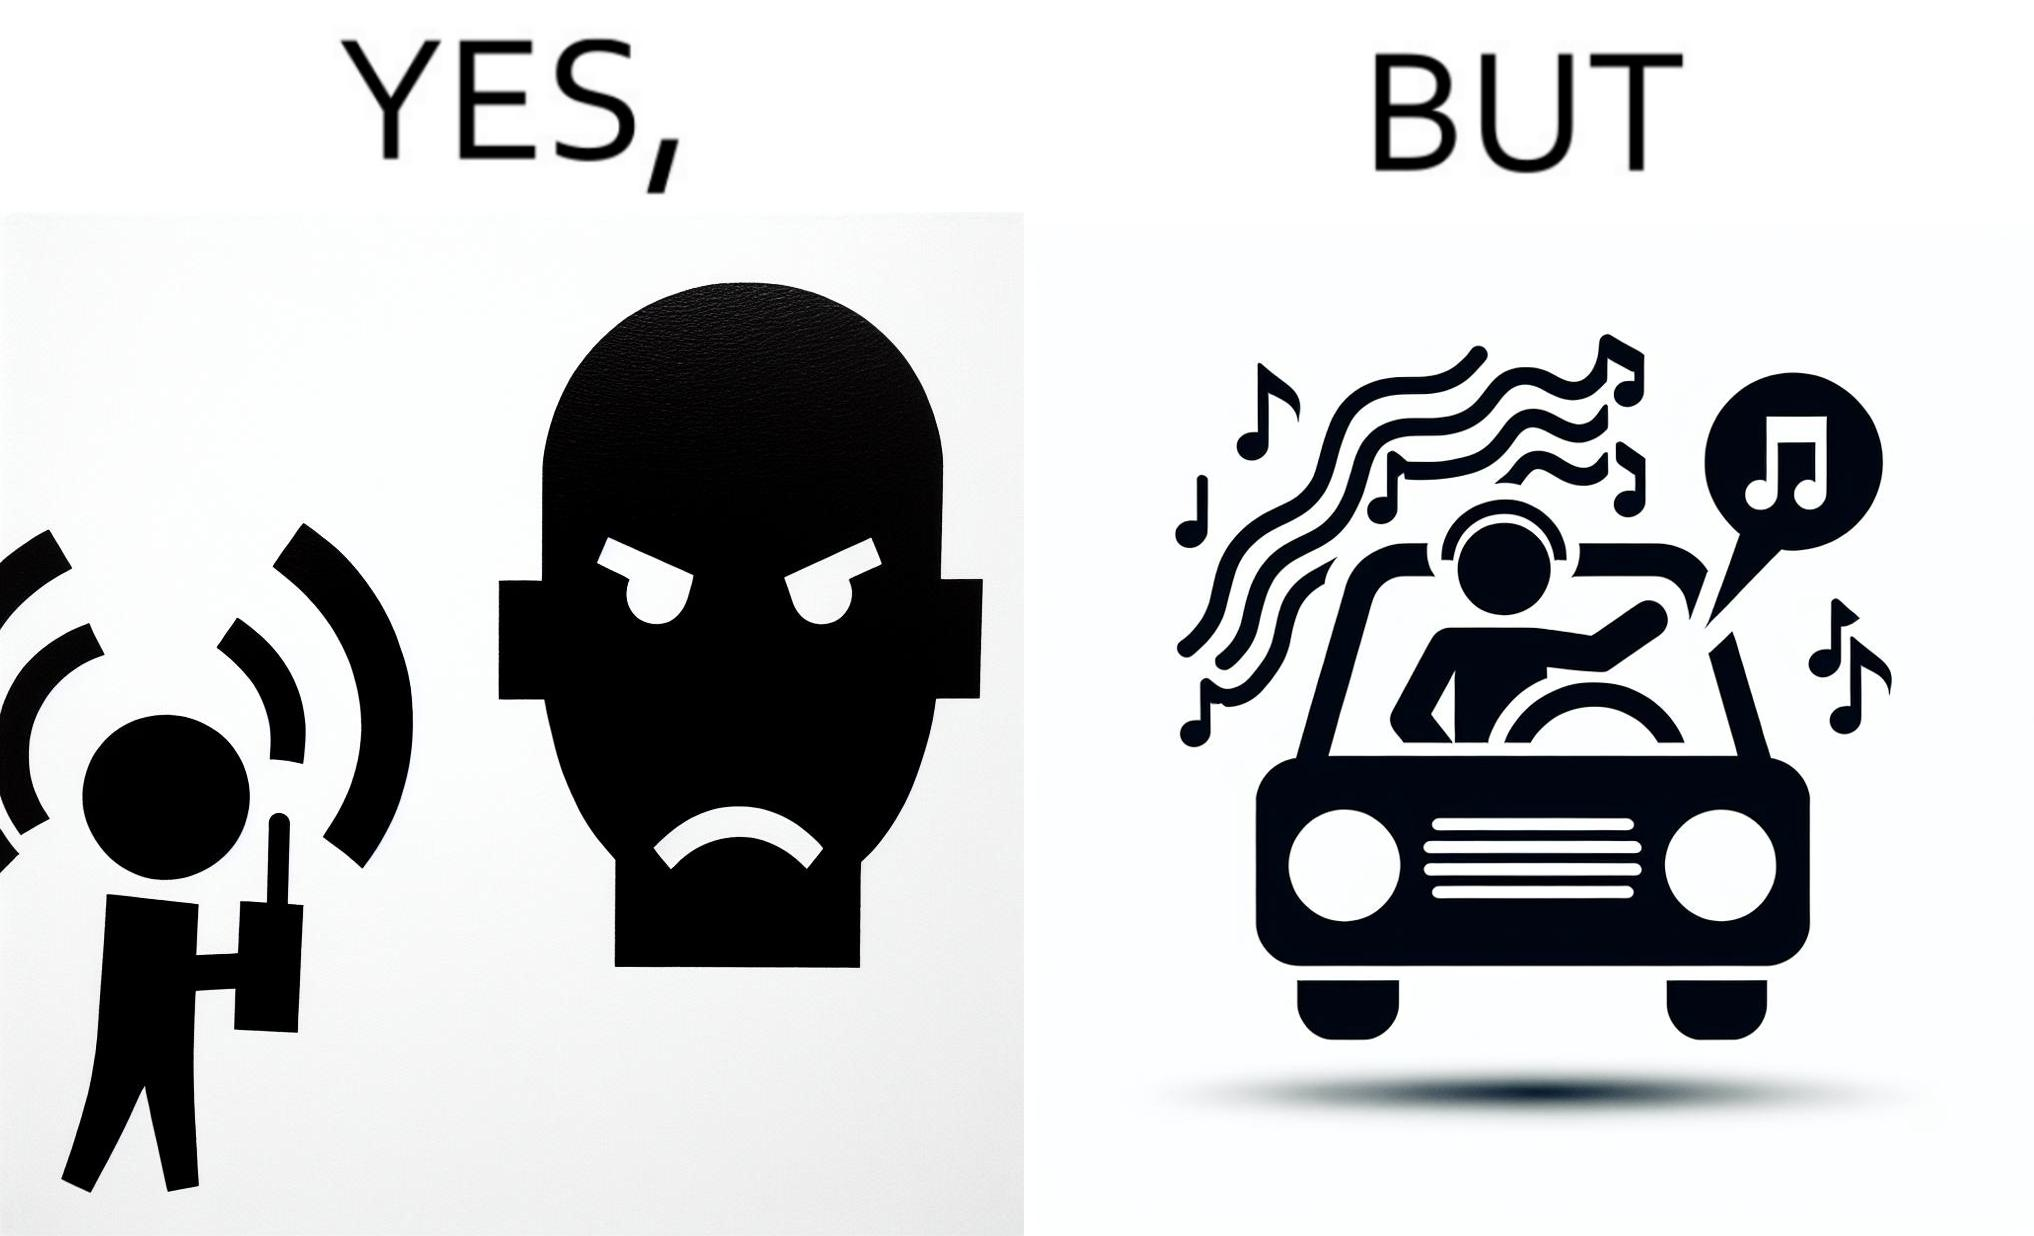Compare the left and right sides of this image. In the left part of the image: The image shows a boy playing music on his phone loudly. The image also shows another man annoyed by the loud music. In the right part of the image: The image shows a man driving a car with the windows of the car rolled down. He has one of his hands on the steering wheel and the other hand hanging out of the window of the driver side of the car. The man is playing loud music in his car with the sound coming out of the car. 